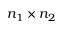<formula> <loc_0><loc_0><loc_500><loc_500>n _ { 1 } \times n _ { 2 }</formula> 